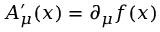Convert formula to latex. <formula><loc_0><loc_0><loc_500><loc_500>A _ { \mu } ^ { \prime } ( x ) = \partial _ { \mu } f ( x )</formula> 